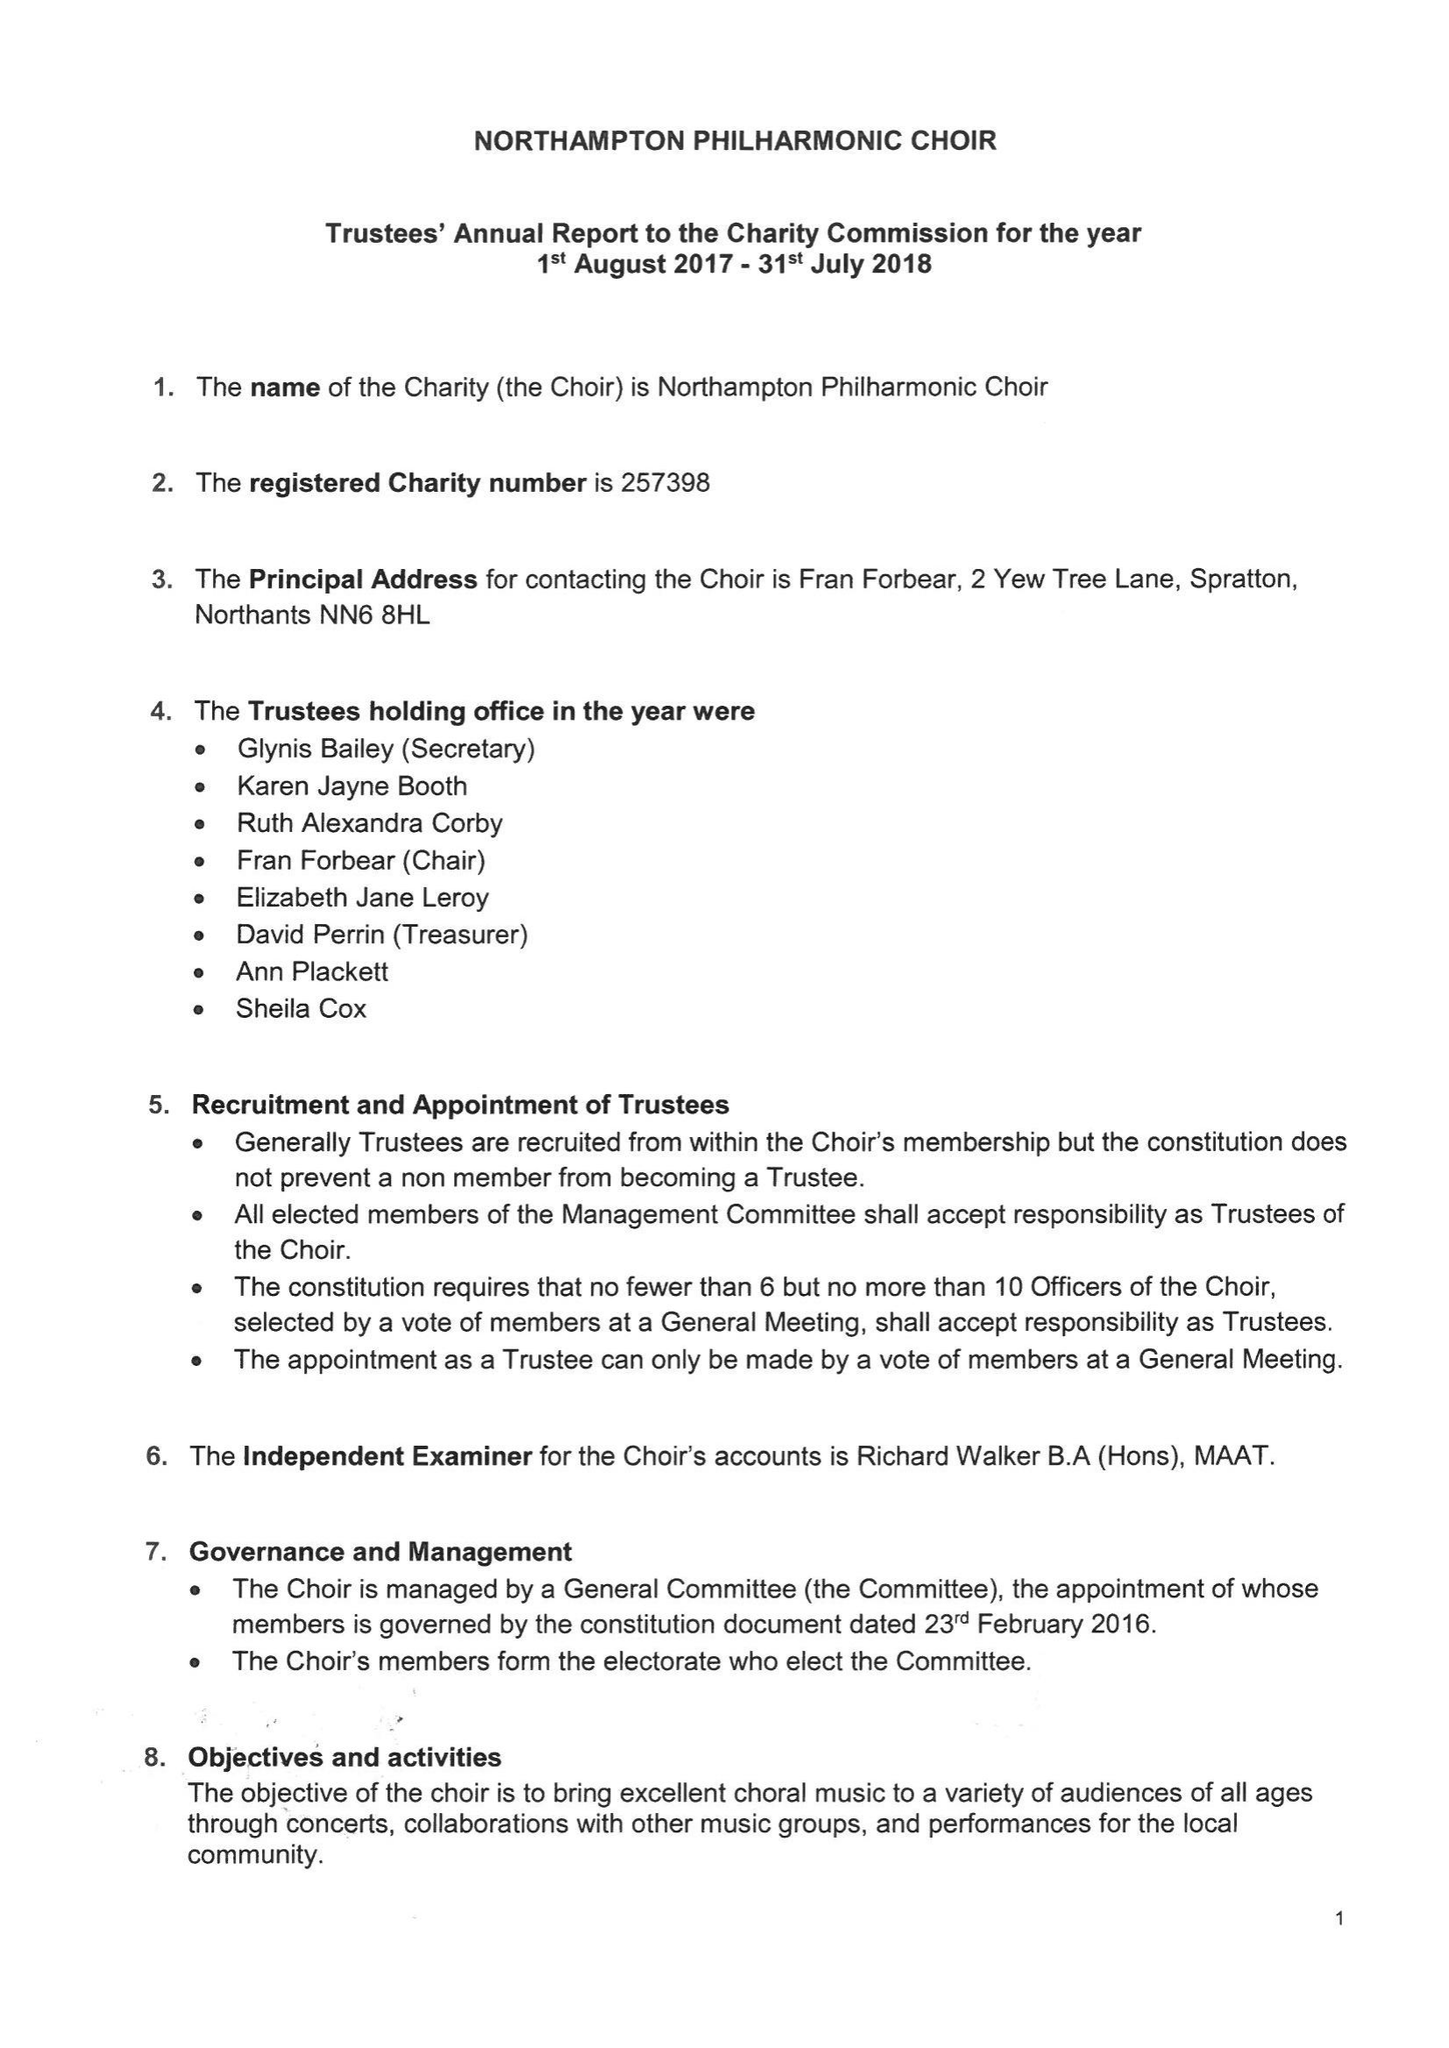What is the value for the charity_number?
Answer the question using a single word or phrase. 257398 